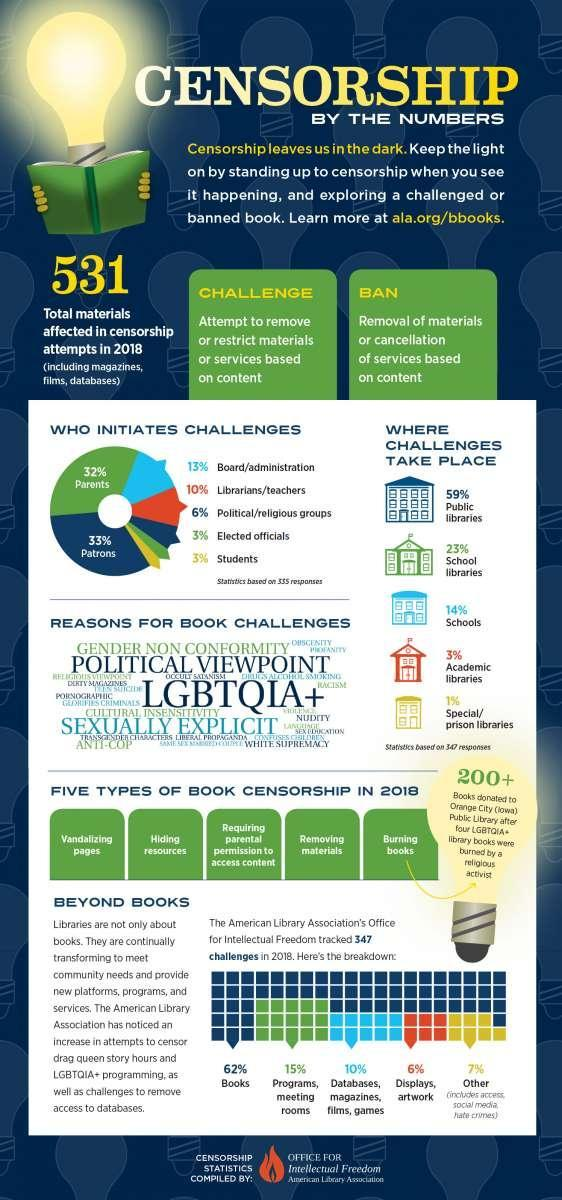What percentage of challenges takes place in school libraries according to the statistics of the American Library Association?
Answer the question with a short phrase. 23% What is the total number of materials affected in censorship attempts in 2018? 531 Who contributes the most to initiate a challenge as per the statistics of American Library Association? Patrons What percentage of books were challenged according to the statistics of the American Library Association in 2018? 62% What percentage of the challenges are initiated by the political or religious groups as per the statistics of the American Library Association? 6% What percentage of challenges takes place in academic libraries according to the statistics of the American Library Association? 3% In which place, the major percentage of challenges takes place according to the statistics of the American Library Association? Public Libraries What percentage of displays & art works were challenged as per the statistics of the American Library Association in 2018? 6% What percentage of the challenges are initiated by the Librarians or teachers as per the statistics of the American Library Association? 10% 